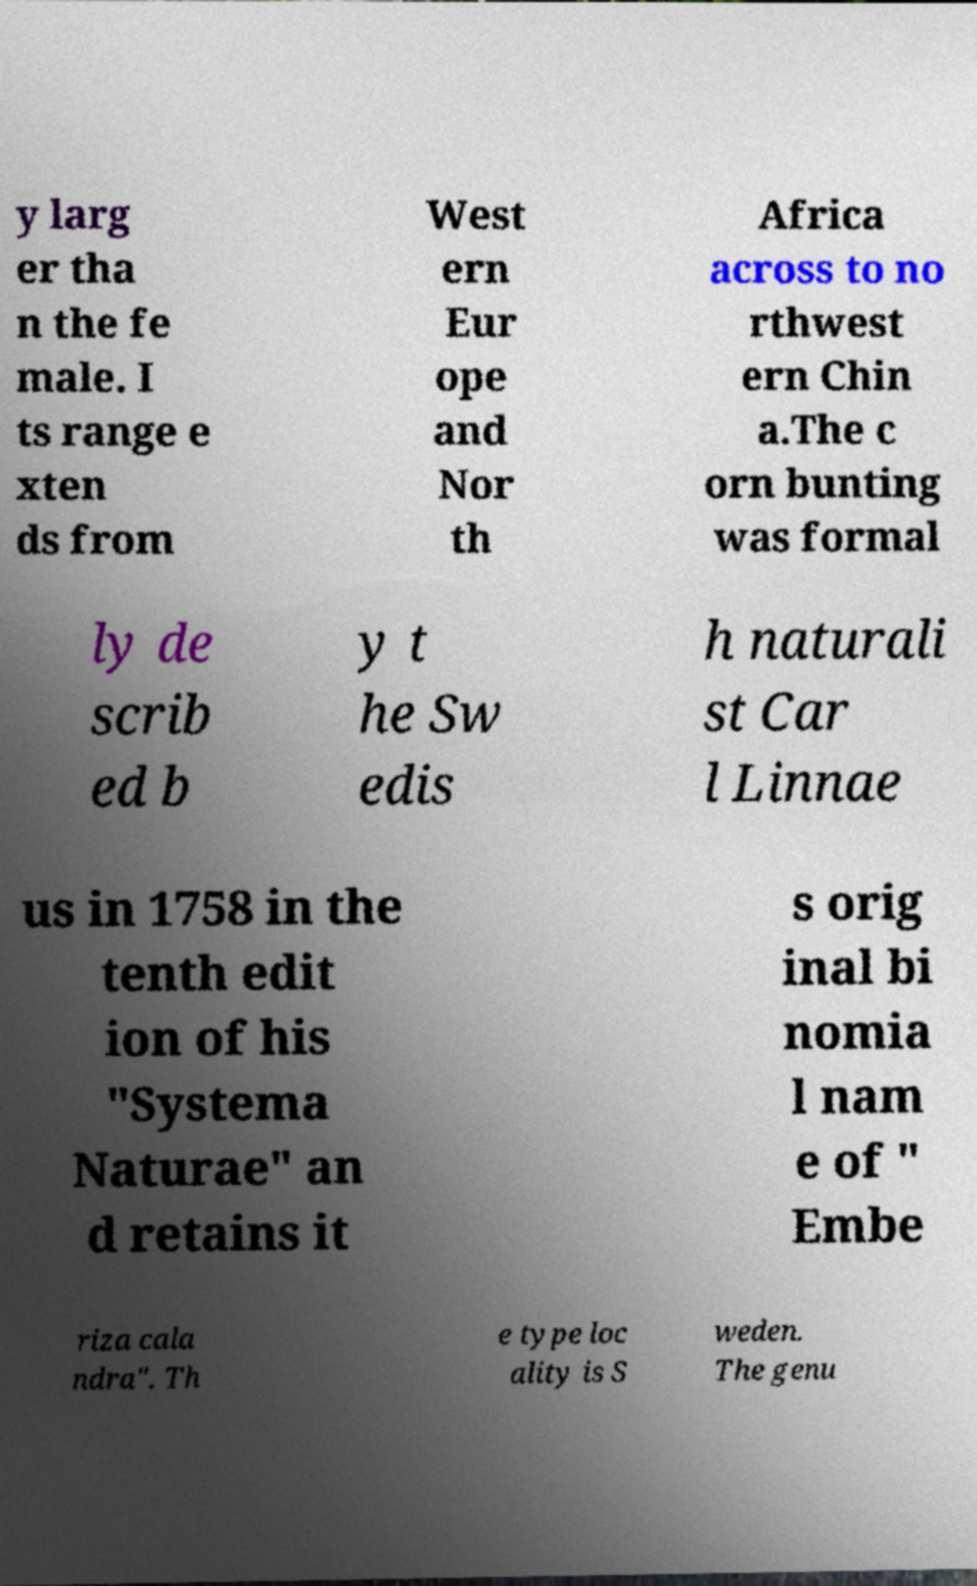Can you read and provide the text displayed in the image?This photo seems to have some interesting text. Can you extract and type it out for me? y larg er tha n the fe male. I ts range e xten ds from West ern Eur ope and Nor th Africa across to no rthwest ern Chin a.The c orn bunting was formal ly de scrib ed b y t he Sw edis h naturali st Car l Linnae us in 1758 in the tenth edit ion of his "Systema Naturae" an d retains it s orig inal bi nomia l nam e of " Embe riza cala ndra". Th e type loc ality is S weden. The genu 